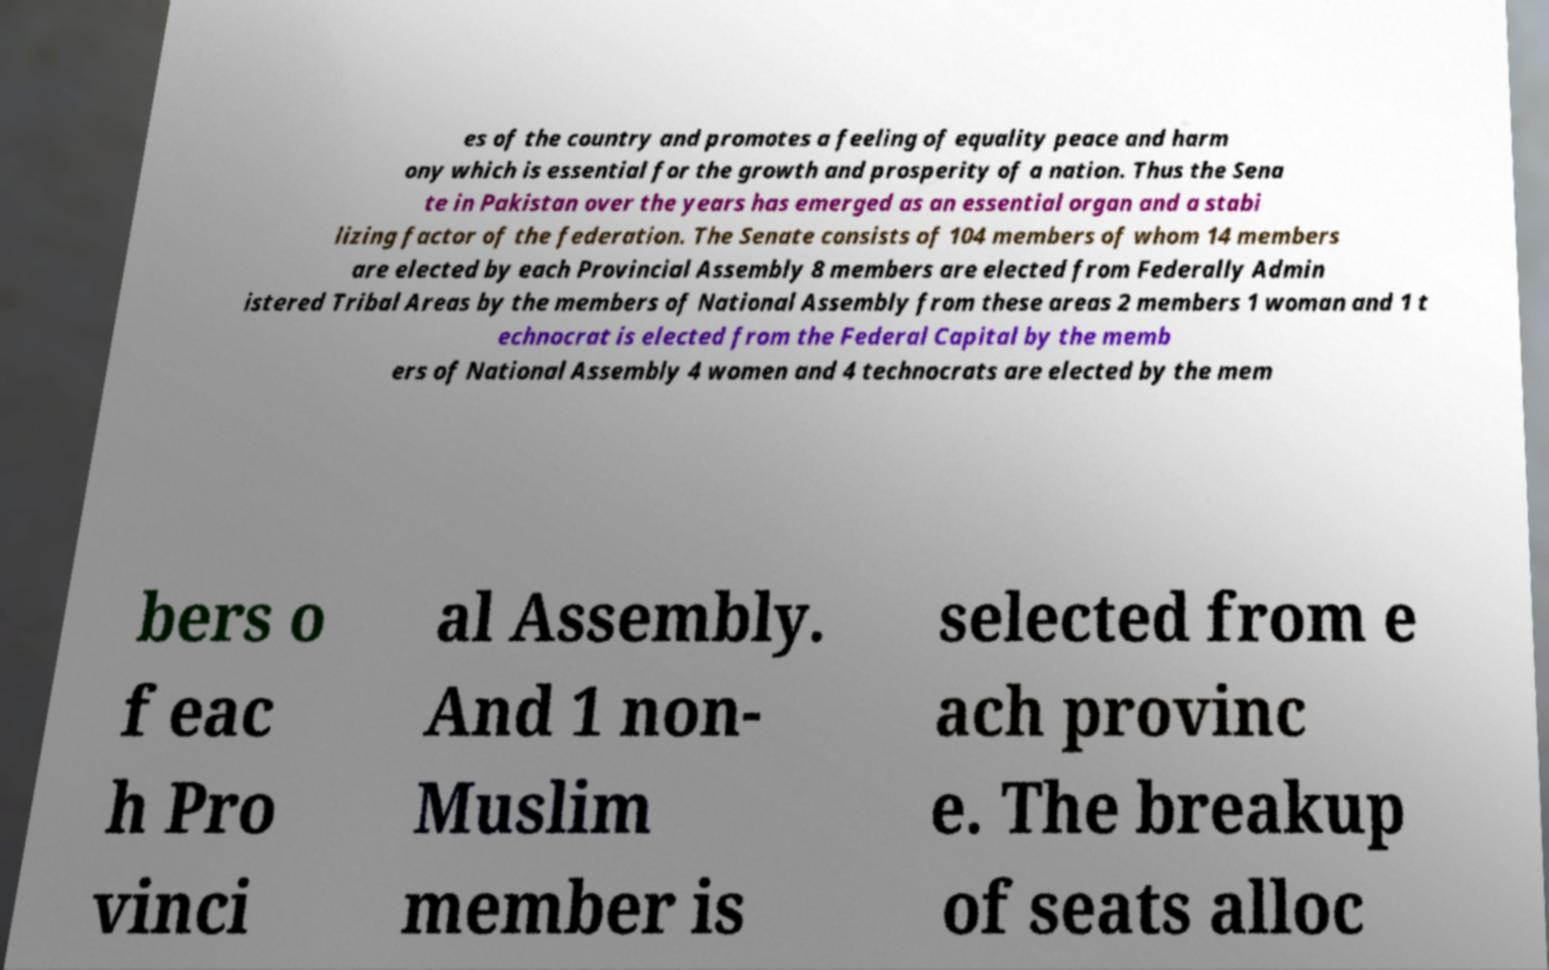What messages or text are displayed in this image? I need them in a readable, typed format. es of the country and promotes a feeling of equality peace and harm ony which is essential for the growth and prosperity of a nation. Thus the Sena te in Pakistan over the years has emerged as an essential organ and a stabi lizing factor of the federation. The Senate consists of 104 members of whom 14 members are elected by each Provincial Assembly 8 members are elected from Federally Admin istered Tribal Areas by the members of National Assembly from these areas 2 members 1 woman and 1 t echnocrat is elected from the Federal Capital by the memb ers of National Assembly 4 women and 4 technocrats are elected by the mem bers o f eac h Pro vinci al Assembly. And 1 non- Muslim member is selected from e ach provinc e. The breakup of seats alloc 